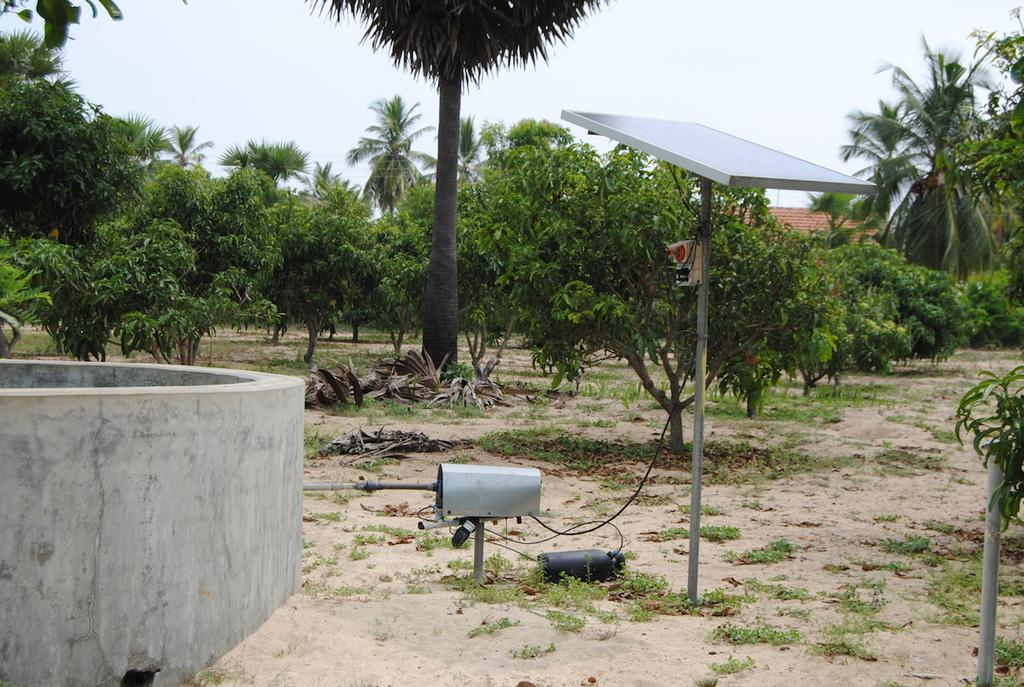What structure is present in the image? There is a well in the image. What type of vegetation can be seen in the image? There are trees in the image. What is covering the ground in the image? There is grass on the ground in the image. What device is present in the image that generates electricity? There is a solar panel in the image. What can be seen in the background of the image? The sky is visible in the background of the image. What type of suit is the well wearing in the image? The well is not wearing a suit, as it is an inanimate structure. 